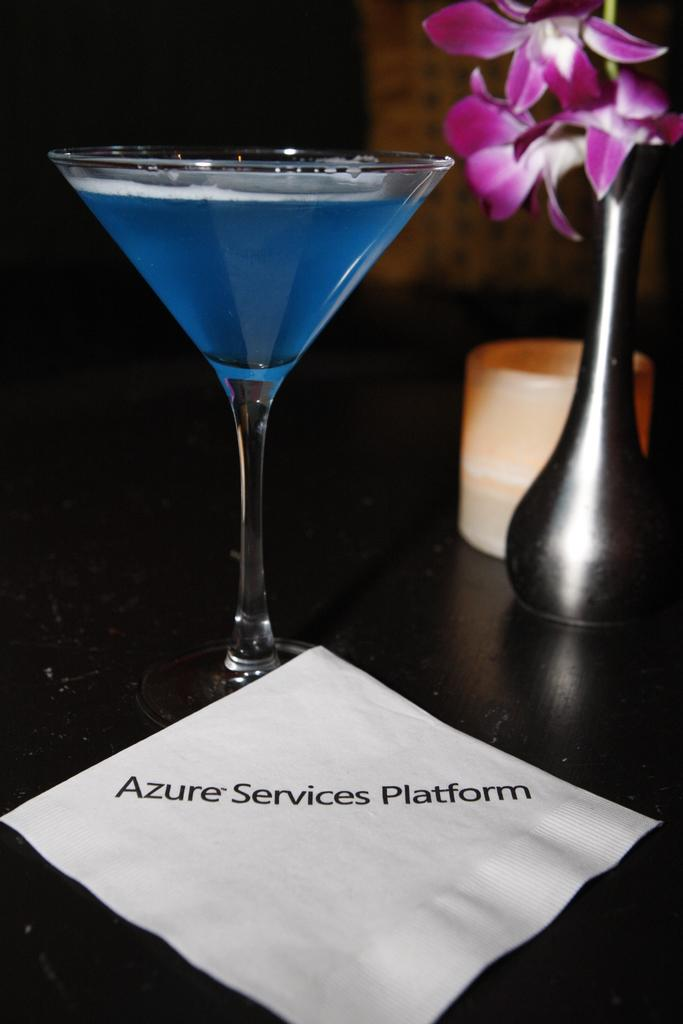What type of glassware is on the table in the image? There is a wine glass on the table in the image. What other object is on the table? There is a flower vase on the table. What else can be seen on the table? There is a cup on the table. What is the title of the piece of paper on the table? The piece of paper is titled "azure services platform." What month is depicted on the calendar in the image? There is no calendar present in the image, so it is not possible to determine the month. 